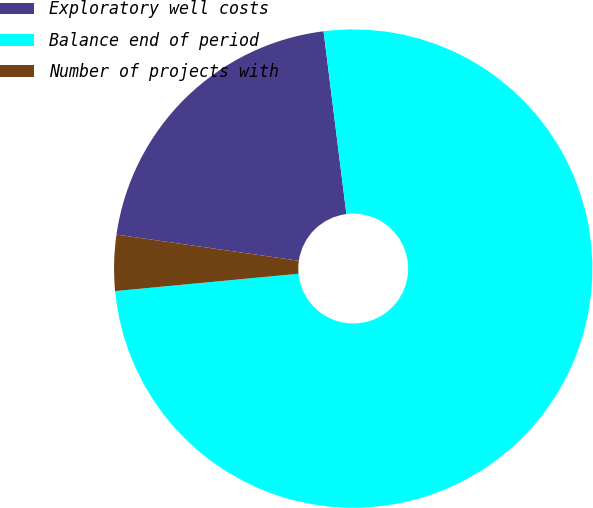Convert chart to OTSL. <chart><loc_0><loc_0><loc_500><loc_500><pie_chart><fcel>Exploratory well costs<fcel>Balance end of period<fcel>Number of projects with<nl><fcel>20.75%<fcel>75.47%<fcel>3.77%<nl></chart> 